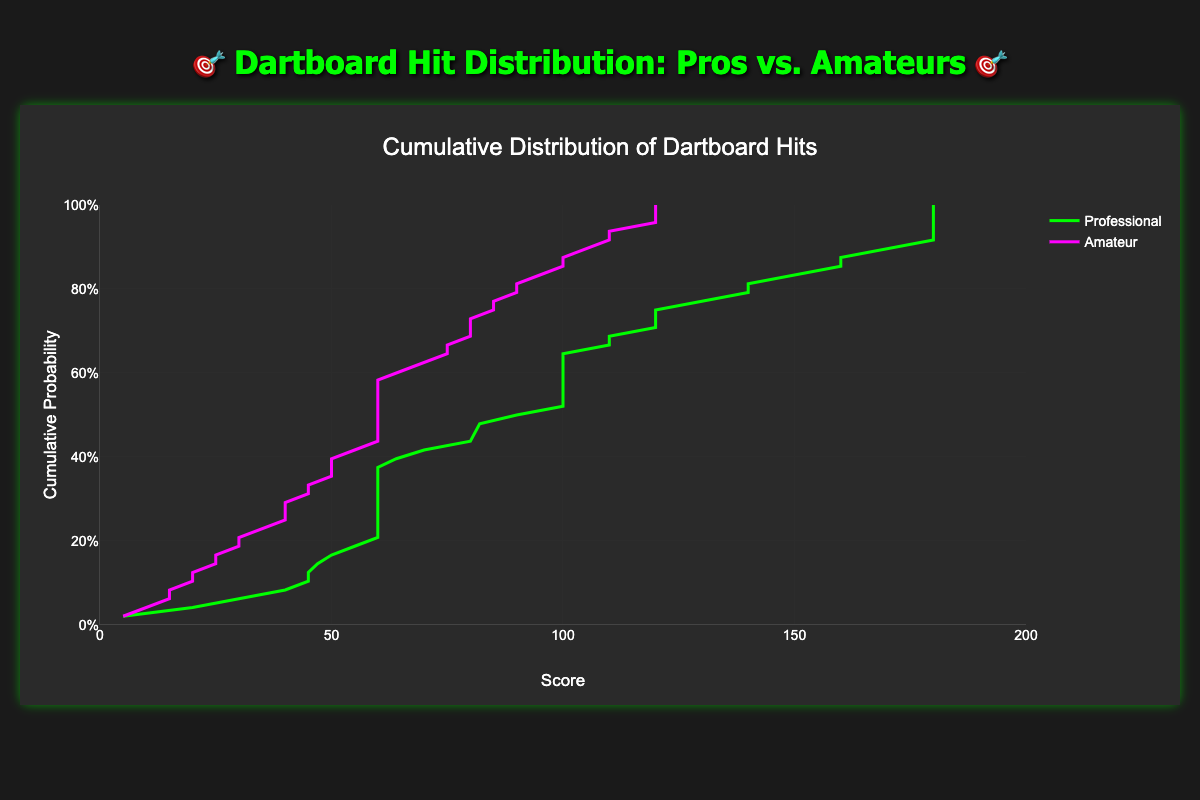How do professional players' scores generally compare to amateur players based on cumulative probability on the plot? The cumulative distribution curves show that professional players maintain higher cumulative probabilities for higher scores compared to amateurs. This indicates that professionals hit higher scores more frequently and reliably.
Answer: Professionals hit higher scores more reliably What is the highest score that has been hit with a 100% cumulative probability by amateurs? The highest score with a 100% cumulative probability for amateurs is identified where the amateur cumulative distribution curve plateaus at the maximum cumulative probability (1). From the plot, this is approximately at the score of 10.
Answer: 10 Around what score do professional players reach a cumulative probability of 50%? To find this, locate where the professional cumulative distribution line crosses the 50% cumulative probability mark on the y-axis, then project this point down to the x-axis. This intersection occurs around a score of 100.
Answer: 100 How does the cumulative probability at a score of 180 compare between professional and amateur players? To determine this, locate the score of 180 on the x-axis and read the corresponding cumulative probabilities for both professional and amateur curves. The cumulative probability for professional players is higher than for amateurs at this score.
Answer: Higher for professionals What is the range of scores where the largest difference in cumulative probability between professionals and amateurs is observed? By analyzing the space between the two curves, the largest gap occurs roughly between scores of 100 and 180, where professionals show a notably higher cumulative probability than amateurs.
Answer: 100-180 What color represents the professional players' data on the plot? The plot legend or context likely indicates that professional players are represented by the green line.
Answer: Green Does the cumulative probability of amateurs reaching a score of 140 exceed 40%? On the plot, at the score of 140 on the x-axis, the cumulative probability for the amateur line is checked. It is less than 40%, indicating they do not exceed this mark.
Answer: No Which group has achieved higher scores more consistently? Observing the rightward shifts and heights of the cumulative distribution curves, professionals have consistently achieved higher scores more frequently and reliably.
Answer: Professionals 